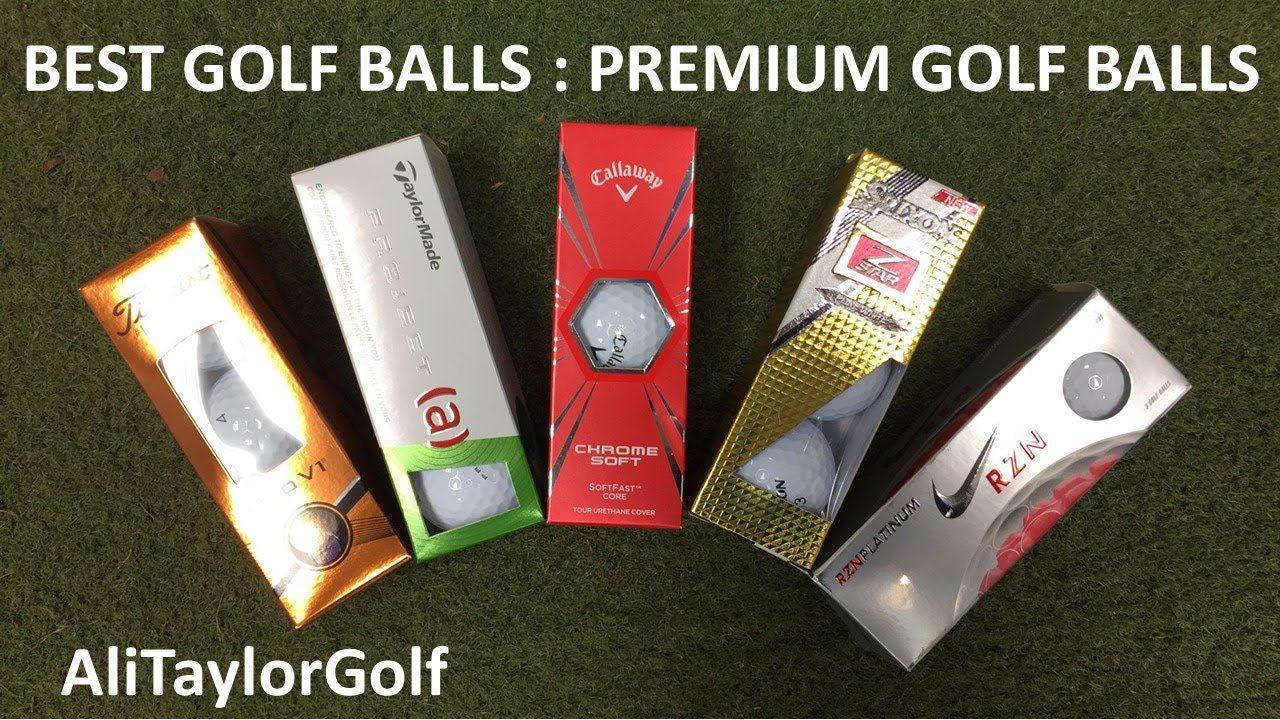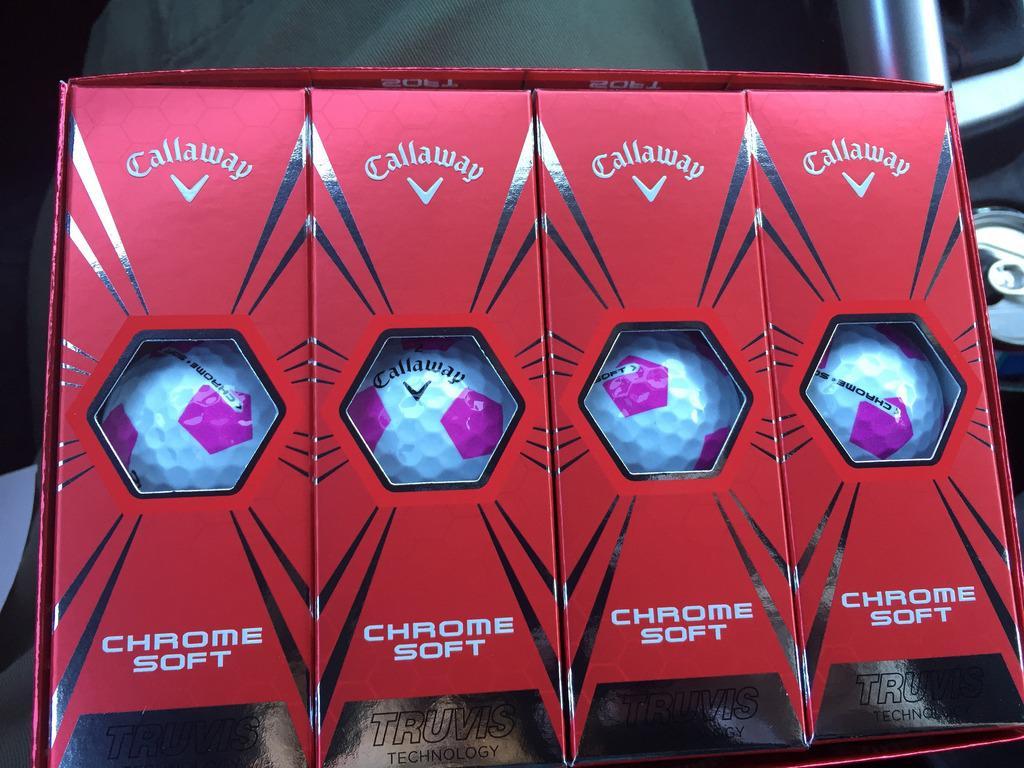The first image is the image on the left, the second image is the image on the right. Examine the images to the left and right. Is the description "All golf balls are in boxes, a total of at least nine boxes of balls are shown, and some boxes have hexagon 'windows' at the center." accurate? Answer yes or no. Yes. The first image is the image on the left, the second image is the image on the right. Evaluate the accuracy of this statement regarding the images: "All the golf balls are in boxes.". Is it true? Answer yes or no. Yes. 